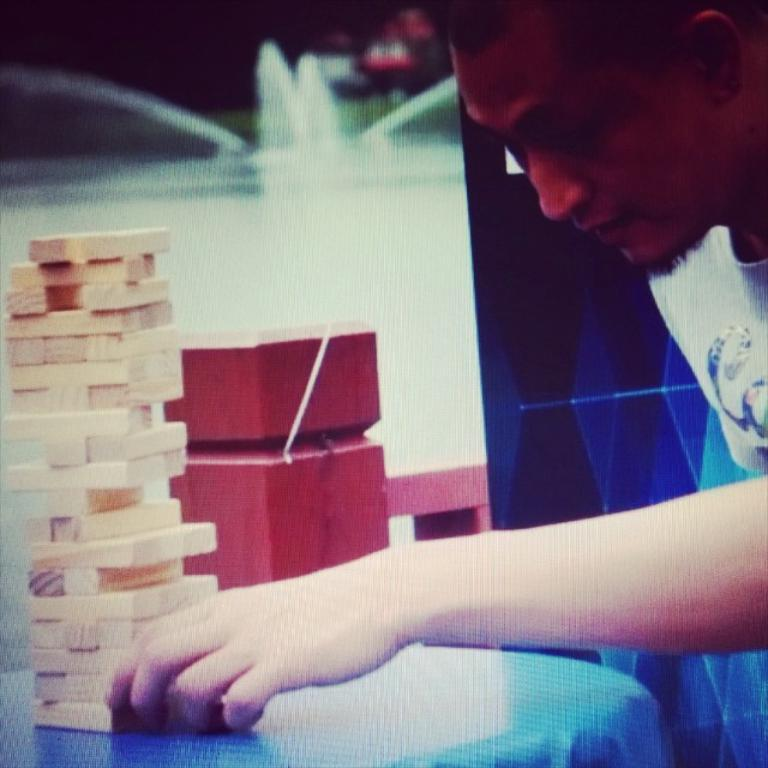What is the main object in the image? There is a table in the image. What is placed on the table? There are wooden blocks on the table. table. What type of game are the wooden blocks part of? The wooden blocks are part of a game called Jenga. Can you describe the person in the image? There is a person to the right of the table. What can be seen in the background of the image? There is a water fountain in the background of the image. What type of honey is being poured on the person's wrist in the image? There is no honey or wrist visible in the image; it only features a table, wooden blocks, a person, and a water fountain in the background. 